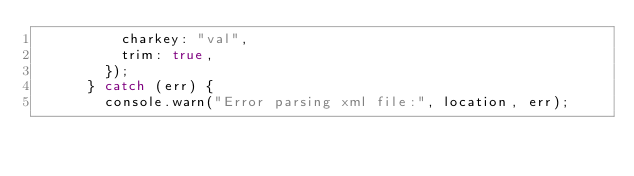<code> <loc_0><loc_0><loc_500><loc_500><_JavaScript_>          charkey: "val",
          trim: true,
        });
      } catch (err) {
        console.warn("Error parsing xml file:", location, err);</code> 